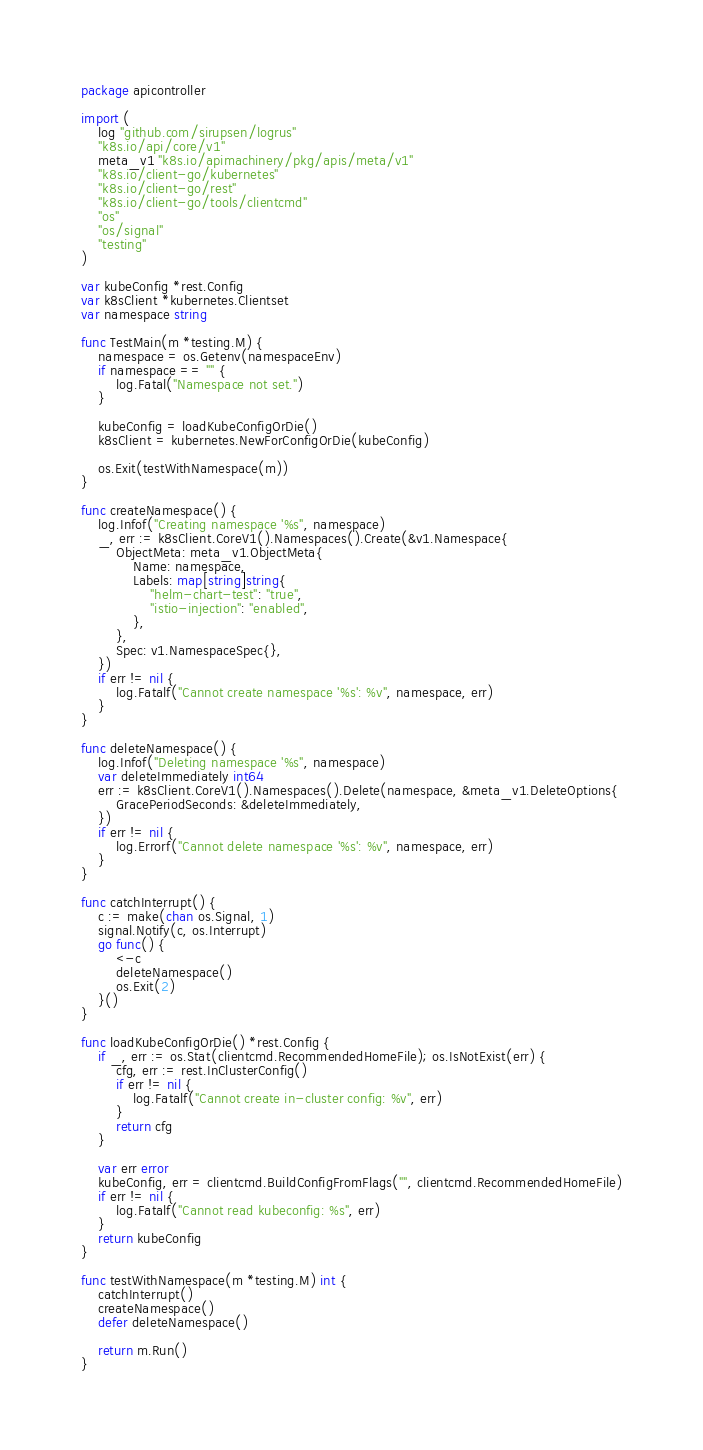Convert code to text. <code><loc_0><loc_0><loc_500><loc_500><_Go_>package apicontroller

import (
	log "github.com/sirupsen/logrus"
	"k8s.io/api/core/v1"
	meta_v1 "k8s.io/apimachinery/pkg/apis/meta/v1"
	"k8s.io/client-go/kubernetes"
	"k8s.io/client-go/rest"
	"k8s.io/client-go/tools/clientcmd"
	"os"
	"os/signal"
	"testing"
)

var kubeConfig *rest.Config
var k8sClient *kubernetes.Clientset
var namespace string

func TestMain(m *testing.M) {
	namespace = os.Getenv(namespaceEnv)
	if namespace == "" {
		log.Fatal("Namespace not set.")
	}

	kubeConfig = loadKubeConfigOrDie()
	k8sClient = kubernetes.NewForConfigOrDie(kubeConfig)

	os.Exit(testWithNamespace(m))
}

func createNamespace() {
	log.Infof("Creating namespace '%s", namespace)
	_, err := k8sClient.CoreV1().Namespaces().Create(&v1.Namespace{
		ObjectMeta: meta_v1.ObjectMeta{
			Name: namespace,
			Labels: map[string]string{
				"helm-chart-test": "true",
				"istio-injection": "enabled",
			},
		},
		Spec: v1.NamespaceSpec{},
	})
	if err != nil {
		log.Fatalf("Cannot create namespace '%s': %v", namespace, err)
	}
}

func deleteNamespace() {
	log.Infof("Deleting namespace '%s", namespace)
	var deleteImmediately int64
	err := k8sClient.CoreV1().Namespaces().Delete(namespace, &meta_v1.DeleteOptions{
		GracePeriodSeconds: &deleteImmediately,
	})
	if err != nil {
		log.Errorf("Cannot delete namespace '%s': %v", namespace, err)
	}
}

func catchInterrupt() {
	c := make(chan os.Signal, 1)
	signal.Notify(c, os.Interrupt)
	go func() {
		<-c
		deleteNamespace()
		os.Exit(2)
	}()
}

func loadKubeConfigOrDie() *rest.Config {
	if _, err := os.Stat(clientcmd.RecommendedHomeFile); os.IsNotExist(err) {
		cfg, err := rest.InClusterConfig()
		if err != nil {
			log.Fatalf("Cannot create in-cluster config: %v", err)
		}
		return cfg
	}

	var err error
	kubeConfig, err = clientcmd.BuildConfigFromFlags("", clientcmd.RecommendedHomeFile)
	if err != nil {
		log.Fatalf("Cannot read kubeconfig: %s", err)
	}
	return kubeConfig
}

func testWithNamespace(m *testing.M) int {
	catchInterrupt()
	createNamespace()
	defer deleteNamespace()

	return m.Run()
}
</code> 